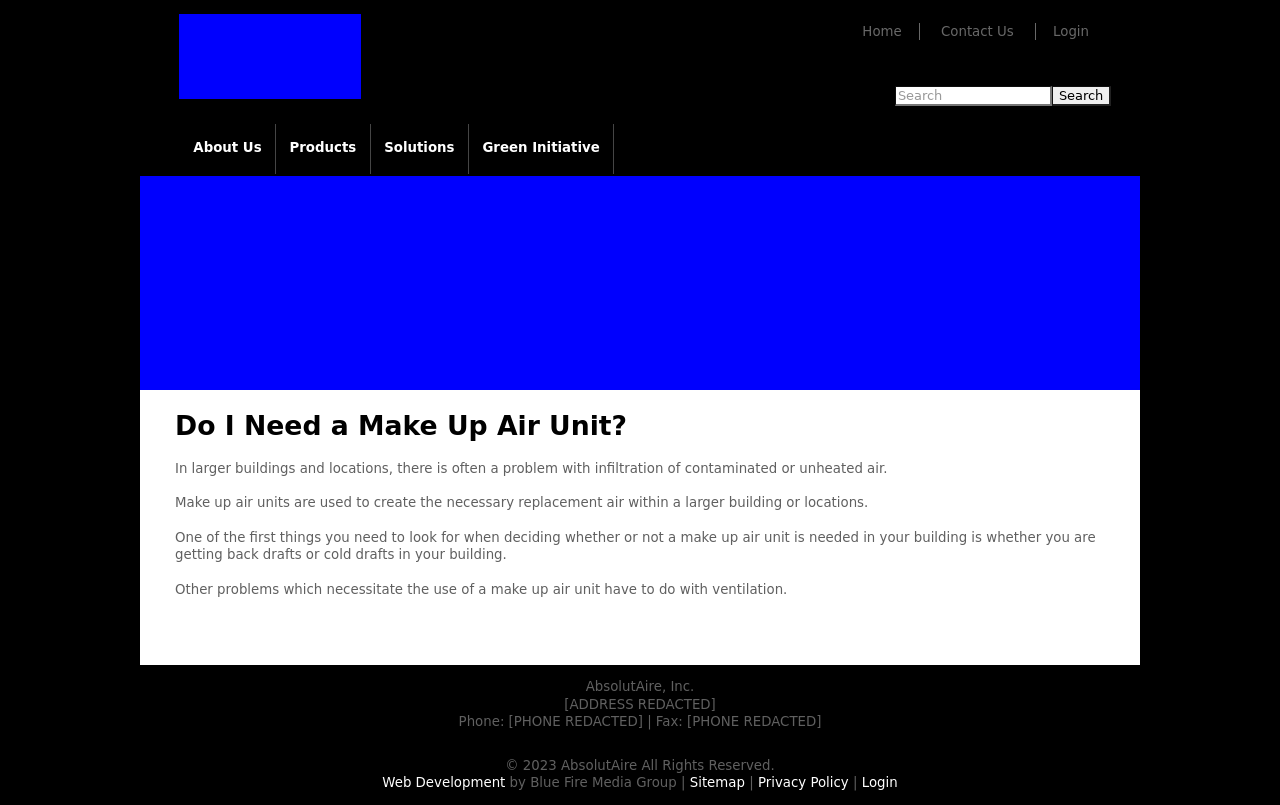Could you detail the process for assembling this website using HTML? To assemble a website like the one shown in the image, using HTML, you would begin by defining the structure of your page with HTML tags. Start with a basic document structure that includes `<!DOCTYPE html>`, `<html>`, `<head>`, and `<body>` sections. Within the `head`, you can link CSS for styling. Inside the `body`, use tags like `<div>`, `<header>`, `<nav>`, and `<footer>` to define the layout. Utilize `<h1>` to `<h6>` for headings, `<p>` for paragraphs, and `<img>` for images. You can use `<a>` tags for links. This structure gives you a clean, navigable website with sections similar to those visible in the screenshot, which include a top navigation bar, a main content area, and a footer. 